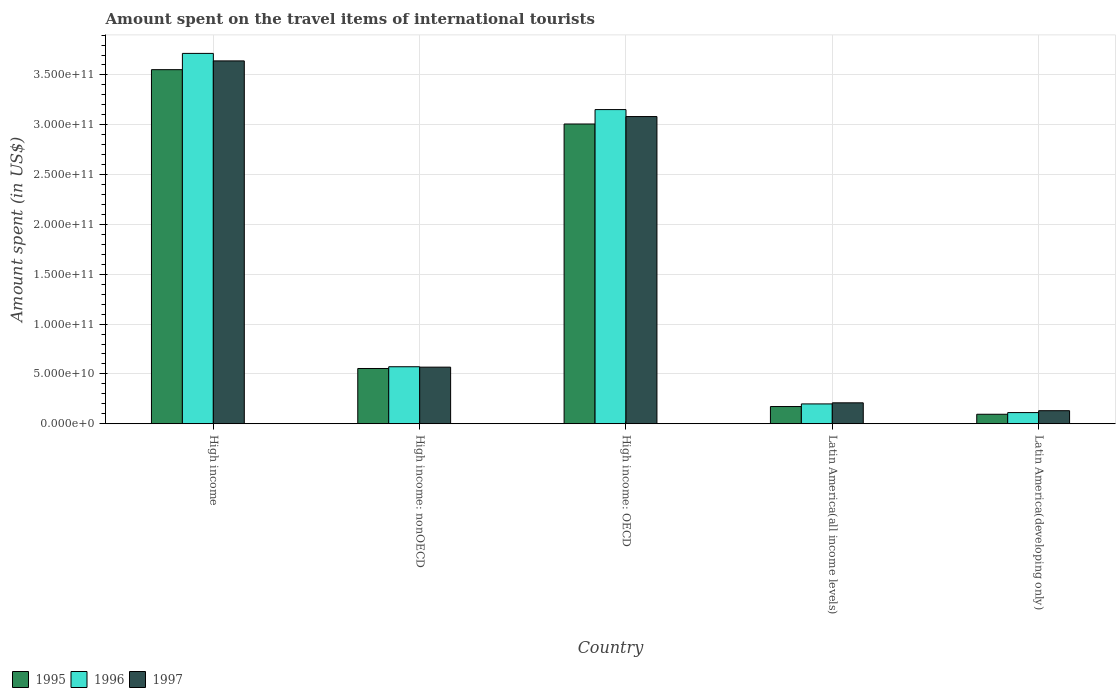How many different coloured bars are there?
Provide a short and direct response. 3. How many groups of bars are there?
Give a very brief answer. 5. Are the number of bars per tick equal to the number of legend labels?
Provide a succinct answer. Yes. What is the label of the 5th group of bars from the left?
Ensure brevity in your answer.  Latin America(developing only). What is the amount spent on the travel items of international tourists in 1995 in High income?
Ensure brevity in your answer.  3.55e+11. Across all countries, what is the maximum amount spent on the travel items of international tourists in 1995?
Your answer should be compact. 3.55e+11. Across all countries, what is the minimum amount spent on the travel items of international tourists in 1996?
Ensure brevity in your answer.  1.12e+1. In which country was the amount spent on the travel items of international tourists in 1995 maximum?
Ensure brevity in your answer.  High income. In which country was the amount spent on the travel items of international tourists in 1996 minimum?
Give a very brief answer. Latin America(developing only). What is the total amount spent on the travel items of international tourists in 1996 in the graph?
Provide a short and direct response. 7.75e+11. What is the difference between the amount spent on the travel items of international tourists in 1997 in High income: OECD and that in Latin America(all income levels)?
Make the answer very short. 2.87e+11. What is the difference between the amount spent on the travel items of international tourists in 1996 in Latin America(all income levels) and the amount spent on the travel items of international tourists in 1997 in High income: nonOECD?
Provide a short and direct response. -3.69e+1. What is the average amount spent on the travel items of international tourists in 1995 per country?
Ensure brevity in your answer.  1.48e+11. What is the difference between the amount spent on the travel items of international tourists of/in 1996 and amount spent on the travel items of international tourists of/in 1995 in High income?
Your answer should be compact. 1.63e+1. In how many countries, is the amount spent on the travel items of international tourists in 1995 greater than 260000000000 US$?
Ensure brevity in your answer.  2. What is the ratio of the amount spent on the travel items of international tourists in 1995 in High income: OECD to that in Latin America(all income levels)?
Offer a very short reply. 17.42. What is the difference between the highest and the second highest amount spent on the travel items of international tourists in 1997?
Provide a short and direct response. -5.59e+1. What is the difference between the highest and the lowest amount spent on the travel items of international tourists in 1997?
Your response must be concise. 3.51e+11. In how many countries, is the amount spent on the travel items of international tourists in 1997 greater than the average amount spent on the travel items of international tourists in 1997 taken over all countries?
Your response must be concise. 2. Is the sum of the amount spent on the travel items of international tourists in 1997 in High income: OECD and Latin America(developing only) greater than the maximum amount spent on the travel items of international tourists in 1995 across all countries?
Ensure brevity in your answer.  No. What does the 2nd bar from the right in High income represents?
Offer a terse response. 1996. How many bars are there?
Your answer should be compact. 15. Does the graph contain any zero values?
Give a very brief answer. No. Does the graph contain grids?
Offer a terse response. Yes. How many legend labels are there?
Keep it short and to the point. 3. What is the title of the graph?
Provide a succinct answer. Amount spent on the travel items of international tourists. What is the label or title of the X-axis?
Ensure brevity in your answer.  Country. What is the label or title of the Y-axis?
Keep it short and to the point. Amount spent (in US$). What is the Amount spent (in US$) of 1995 in High income?
Offer a very short reply. 3.55e+11. What is the Amount spent (in US$) of 1996 in High income?
Your answer should be very brief. 3.72e+11. What is the Amount spent (in US$) of 1997 in High income?
Give a very brief answer. 3.64e+11. What is the Amount spent (in US$) of 1995 in High income: nonOECD?
Ensure brevity in your answer.  5.54e+1. What is the Amount spent (in US$) of 1996 in High income: nonOECD?
Keep it short and to the point. 5.72e+1. What is the Amount spent (in US$) of 1997 in High income: nonOECD?
Provide a short and direct response. 5.68e+1. What is the Amount spent (in US$) of 1995 in High income: OECD?
Keep it short and to the point. 3.01e+11. What is the Amount spent (in US$) of 1996 in High income: OECD?
Make the answer very short. 3.15e+11. What is the Amount spent (in US$) in 1997 in High income: OECD?
Make the answer very short. 3.08e+11. What is the Amount spent (in US$) of 1995 in Latin America(all income levels)?
Your answer should be compact. 1.73e+1. What is the Amount spent (in US$) in 1996 in Latin America(all income levels)?
Give a very brief answer. 1.99e+1. What is the Amount spent (in US$) in 1997 in Latin America(all income levels)?
Provide a succinct answer. 2.10e+1. What is the Amount spent (in US$) in 1995 in Latin America(developing only)?
Ensure brevity in your answer.  9.52e+09. What is the Amount spent (in US$) in 1996 in Latin America(developing only)?
Keep it short and to the point. 1.12e+1. What is the Amount spent (in US$) in 1997 in Latin America(developing only)?
Your answer should be very brief. 1.31e+1. Across all countries, what is the maximum Amount spent (in US$) of 1995?
Offer a terse response. 3.55e+11. Across all countries, what is the maximum Amount spent (in US$) of 1996?
Ensure brevity in your answer.  3.72e+11. Across all countries, what is the maximum Amount spent (in US$) in 1997?
Offer a very short reply. 3.64e+11. Across all countries, what is the minimum Amount spent (in US$) in 1995?
Your response must be concise. 9.52e+09. Across all countries, what is the minimum Amount spent (in US$) of 1996?
Make the answer very short. 1.12e+1. Across all countries, what is the minimum Amount spent (in US$) of 1997?
Ensure brevity in your answer.  1.31e+1. What is the total Amount spent (in US$) of 1995 in the graph?
Ensure brevity in your answer.  7.38e+11. What is the total Amount spent (in US$) in 1996 in the graph?
Offer a terse response. 7.75e+11. What is the total Amount spent (in US$) of 1997 in the graph?
Offer a very short reply. 7.63e+11. What is the difference between the Amount spent (in US$) in 1995 in High income and that in High income: nonOECD?
Keep it short and to the point. 3.00e+11. What is the difference between the Amount spent (in US$) in 1996 in High income and that in High income: nonOECD?
Give a very brief answer. 3.14e+11. What is the difference between the Amount spent (in US$) in 1997 in High income and that in High income: nonOECD?
Give a very brief answer. 3.07e+11. What is the difference between the Amount spent (in US$) of 1995 in High income and that in High income: OECD?
Ensure brevity in your answer.  5.45e+1. What is the difference between the Amount spent (in US$) of 1996 in High income and that in High income: OECD?
Keep it short and to the point. 5.64e+1. What is the difference between the Amount spent (in US$) in 1997 in High income and that in High income: OECD?
Offer a terse response. 5.59e+1. What is the difference between the Amount spent (in US$) in 1995 in High income and that in Latin America(all income levels)?
Make the answer very short. 3.38e+11. What is the difference between the Amount spent (in US$) of 1996 in High income and that in Latin America(all income levels)?
Provide a succinct answer. 3.52e+11. What is the difference between the Amount spent (in US$) of 1997 in High income and that in Latin America(all income levels)?
Provide a succinct answer. 3.43e+11. What is the difference between the Amount spent (in US$) of 1995 in High income and that in Latin America(developing only)?
Your response must be concise. 3.46e+11. What is the difference between the Amount spent (in US$) in 1996 in High income and that in Latin America(developing only)?
Keep it short and to the point. 3.60e+11. What is the difference between the Amount spent (in US$) of 1997 in High income and that in Latin America(developing only)?
Provide a short and direct response. 3.51e+11. What is the difference between the Amount spent (in US$) of 1995 in High income: nonOECD and that in High income: OECD?
Provide a short and direct response. -2.45e+11. What is the difference between the Amount spent (in US$) in 1996 in High income: nonOECD and that in High income: OECD?
Make the answer very short. -2.58e+11. What is the difference between the Amount spent (in US$) of 1997 in High income: nonOECD and that in High income: OECD?
Offer a very short reply. -2.51e+11. What is the difference between the Amount spent (in US$) in 1995 in High income: nonOECD and that in Latin America(all income levels)?
Keep it short and to the point. 3.82e+1. What is the difference between the Amount spent (in US$) of 1996 in High income: nonOECD and that in Latin America(all income levels)?
Offer a very short reply. 3.73e+1. What is the difference between the Amount spent (in US$) of 1997 in High income: nonOECD and that in Latin America(all income levels)?
Offer a terse response. 3.58e+1. What is the difference between the Amount spent (in US$) of 1995 in High income: nonOECD and that in Latin America(developing only)?
Your response must be concise. 4.59e+1. What is the difference between the Amount spent (in US$) of 1996 in High income: nonOECD and that in Latin America(developing only)?
Keep it short and to the point. 4.60e+1. What is the difference between the Amount spent (in US$) in 1997 in High income: nonOECD and that in Latin America(developing only)?
Your response must be concise. 4.37e+1. What is the difference between the Amount spent (in US$) in 1995 in High income: OECD and that in Latin America(all income levels)?
Ensure brevity in your answer.  2.84e+11. What is the difference between the Amount spent (in US$) of 1996 in High income: OECD and that in Latin America(all income levels)?
Ensure brevity in your answer.  2.95e+11. What is the difference between the Amount spent (in US$) of 1997 in High income: OECD and that in Latin America(all income levels)?
Keep it short and to the point. 2.87e+11. What is the difference between the Amount spent (in US$) of 1995 in High income: OECD and that in Latin America(developing only)?
Provide a succinct answer. 2.91e+11. What is the difference between the Amount spent (in US$) of 1996 in High income: OECD and that in Latin America(developing only)?
Provide a short and direct response. 3.04e+11. What is the difference between the Amount spent (in US$) of 1997 in High income: OECD and that in Latin America(developing only)?
Provide a succinct answer. 2.95e+11. What is the difference between the Amount spent (in US$) in 1995 in Latin America(all income levels) and that in Latin America(developing only)?
Make the answer very short. 7.75e+09. What is the difference between the Amount spent (in US$) of 1996 in Latin America(all income levels) and that in Latin America(developing only)?
Make the answer very short. 8.70e+09. What is the difference between the Amount spent (in US$) in 1997 in Latin America(all income levels) and that in Latin America(developing only)?
Keep it short and to the point. 7.89e+09. What is the difference between the Amount spent (in US$) of 1995 in High income and the Amount spent (in US$) of 1996 in High income: nonOECD?
Make the answer very short. 2.98e+11. What is the difference between the Amount spent (in US$) of 1995 in High income and the Amount spent (in US$) of 1997 in High income: nonOECD?
Offer a very short reply. 2.99e+11. What is the difference between the Amount spent (in US$) in 1996 in High income and the Amount spent (in US$) in 1997 in High income: nonOECD?
Your answer should be very brief. 3.15e+11. What is the difference between the Amount spent (in US$) in 1995 in High income and the Amount spent (in US$) in 1996 in High income: OECD?
Give a very brief answer. 4.01e+1. What is the difference between the Amount spent (in US$) of 1995 in High income and the Amount spent (in US$) of 1997 in High income: OECD?
Your answer should be very brief. 4.71e+1. What is the difference between the Amount spent (in US$) of 1996 in High income and the Amount spent (in US$) of 1997 in High income: OECD?
Your answer should be compact. 6.34e+1. What is the difference between the Amount spent (in US$) in 1995 in High income and the Amount spent (in US$) in 1996 in Latin America(all income levels)?
Keep it short and to the point. 3.35e+11. What is the difference between the Amount spent (in US$) of 1995 in High income and the Amount spent (in US$) of 1997 in Latin America(all income levels)?
Offer a terse response. 3.34e+11. What is the difference between the Amount spent (in US$) in 1996 in High income and the Amount spent (in US$) in 1997 in Latin America(all income levels)?
Ensure brevity in your answer.  3.51e+11. What is the difference between the Amount spent (in US$) in 1995 in High income and the Amount spent (in US$) in 1996 in Latin America(developing only)?
Offer a terse response. 3.44e+11. What is the difference between the Amount spent (in US$) of 1995 in High income and the Amount spent (in US$) of 1997 in Latin America(developing only)?
Offer a terse response. 3.42e+11. What is the difference between the Amount spent (in US$) in 1996 in High income and the Amount spent (in US$) in 1997 in Latin America(developing only)?
Provide a short and direct response. 3.59e+11. What is the difference between the Amount spent (in US$) of 1995 in High income: nonOECD and the Amount spent (in US$) of 1996 in High income: OECD?
Provide a succinct answer. -2.60e+11. What is the difference between the Amount spent (in US$) in 1995 in High income: nonOECD and the Amount spent (in US$) in 1997 in High income: OECD?
Your answer should be compact. -2.53e+11. What is the difference between the Amount spent (in US$) in 1996 in High income: nonOECD and the Amount spent (in US$) in 1997 in High income: OECD?
Your response must be concise. -2.51e+11. What is the difference between the Amount spent (in US$) of 1995 in High income: nonOECD and the Amount spent (in US$) of 1996 in Latin America(all income levels)?
Give a very brief answer. 3.55e+1. What is the difference between the Amount spent (in US$) of 1995 in High income: nonOECD and the Amount spent (in US$) of 1997 in Latin America(all income levels)?
Ensure brevity in your answer.  3.44e+1. What is the difference between the Amount spent (in US$) in 1996 in High income: nonOECD and the Amount spent (in US$) in 1997 in Latin America(all income levels)?
Provide a short and direct response. 3.62e+1. What is the difference between the Amount spent (in US$) in 1995 in High income: nonOECD and the Amount spent (in US$) in 1996 in Latin America(developing only)?
Make the answer very short. 4.42e+1. What is the difference between the Amount spent (in US$) in 1995 in High income: nonOECD and the Amount spent (in US$) in 1997 in Latin America(developing only)?
Give a very brief answer. 4.23e+1. What is the difference between the Amount spent (in US$) in 1996 in High income: nonOECD and the Amount spent (in US$) in 1997 in Latin America(developing only)?
Offer a terse response. 4.41e+1. What is the difference between the Amount spent (in US$) of 1995 in High income: OECD and the Amount spent (in US$) of 1996 in Latin America(all income levels)?
Provide a short and direct response. 2.81e+11. What is the difference between the Amount spent (in US$) of 1995 in High income: OECD and the Amount spent (in US$) of 1997 in Latin America(all income levels)?
Give a very brief answer. 2.80e+11. What is the difference between the Amount spent (in US$) in 1996 in High income: OECD and the Amount spent (in US$) in 1997 in Latin America(all income levels)?
Your answer should be compact. 2.94e+11. What is the difference between the Amount spent (in US$) in 1995 in High income: OECD and the Amount spent (in US$) in 1996 in Latin America(developing only)?
Provide a succinct answer. 2.90e+11. What is the difference between the Amount spent (in US$) in 1995 in High income: OECD and the Amount spent (in US$) in 1997 in Latin America(developing only)?
Offer a very short reply. 2.88e+11. What is the difference between the Amount spent (in US$) in 1996 in High income: OECD and the Amount spent (in US$) in 1997 in Latin America(developing only)?
Provide a short and direct response. 3.02e+11. What is the difference between the Amount spent (in US$) in 1995 in Latin America(all income levels) and the Amount spent (in US$) in 1996 in Latin America(developing only)?
Provide a succinct answer. 6.08e+09. What is the difference between the Amount spent (in US$) in 1995 in Latin America(all income levels) and the Amount spent (in US$) in 1997 in Latin America(developing only)?
Ensure brevity in your answer.  4.17e+09. What is the difference between the Amount spent (in US$) in 1996 in Latin America(all income levels) and the Amount spent (in US$) in 1997 in Latin America(developing only)?
Provide a succinct answer. 6.80e+09. What is the average Amount spent (in US$) in 1995 per country?
Ensure brevity in your answer.  1.48e+11. What is the average Amount spent (in US$) of 1996 per country?
Ensure brevity in your answer.  1.55e+11. What is the average Amount spent (in US$) of 1997 per country?
Keep it short and to the point. 1.53e+11. What is the difference between the Amount spent (in US$) in 1995 and Amount spent (in US$) in 1996 in High income?
Provide a short and direct response. -1.63e+1. What is the difference between the Amount spent (in US$) of 1995 and Amount spent (in US$) of 1997 in High income?
Provide a short and direct response. -8.79e+09. What is the difference between the Amount spent (in US$) of 1996 and Amount spent (in US$) of 1997 in High income?
Provide a succinct answer. 7.54e+09. What is the difference between the Amount spent (in US$) in 1995 and Amount spent (in US$) in 1996 in High income: nonOECD?
Your response must be concise. -1.77e+09. What is the difference between the Amount spent (in US$) of 1995 and Amount spent (in US$) of 1997 in High income: nonOECD?
Your response must be concise. -1.35e+09. What is the difference between the Amount spent (in US$) of 1996 and Amount spent (in US$) of 1997 in High income: nonOECD?
Offer a very short reply. 4.21e+08. What is the difference between the Amount spent (in US$) of 1995 and Amount spent (in US$) of 1996 in High income: OECD?
Ensure brevity in your answer.  -1.45e+1. What is the difference between the Amount spent (in US$) of 1995 and Amount spent (in US$) of 1997 in High income: OECD?
Keep it short and to the point. -7.46e+09. What is the difference between the Amount spent (in US$) of 1996 and Amount spent (in US$) of 1997 in High income: OECD?
Offer a terse response. 7.00e+09. What is the difference between the Amount spent (in US$) in 1995 and Amount spent (in US$) in 1996 in Latin America(all income levels)?
Offer a very short reply. -2.62e+09. What is the difference between the Amount spent (in US$) of 1995 and Amount spent (in US$) of 1997 in Latin America(all income levels)?
Provide a succinct answer. -3.72e+09. What is the difference between the Amount spent (in US$) of 1996 and Amount spent (in US$) of 1997 in Latin America(all income levels)?
Your answer should be very brief. -1.10e+09. What is the difference between the Amount spent (in US$) of 1995 and Amount spent (in US$) of 1996 in Latin America(developing only)?
Offer a terse response. -1.67e+09. What is the difference between the Amount spent (in US$) in 1995 and Amount spent (in US$) in 1997 in Latin America(developing only)?
Provide a short and direct response. -3.58e+09. What is the difference between the Amount spent (in US$) of 1996 and Amount spent (in US$) of 1997 in Latin America(developing only)?
Offer a very short reply. -1.91e+09. What is the ratio of the Amount spent (in US$) of 1995 in High income to that in High income: nonOECD?
Your answer should be very brief. 6.41. What is the ratio of the Amount spent (in US$) of 1996 in High income to that in High income: nonOECD?
Your answer should be very brief. 6.5. What is the ratio of the Amount spent (in US$) in 1997 in High income to that in High income: nonOECD?
Make the answer very short. 6.41. What is the ratio of the Amount spent (in US$) in 1995 in High income to that in High income: OECD?
Keep it short and to the point. 1.18. What is the ratio of the Amount spent (in US$) in 1996 in High income to that in High income: OECD?
Your answer should be very brief. 1.18. What is the ratio of the Amount spent (in US$) of 1997 in High income to that in High income: OECD?
Make the answer very short. 1.18. What is the ratio of the Amount spent (in US$) in 1995 in High income to that in Latin America(all income levels)?
Provide a succinct answer. 20.58. What is the ratio of the Amount spent (in US$) in 1996 in High income to that in Latin America(all income levels)?
Offer a terse response. 18.68. What is the ratio of the Amount spent (in US$) of 1997 in High income to that in Latin America(all income levels)?
Provide a succinct answer. 17.35. What is the ratio of the Amount spent (in US$) of 1995 in High income to that in Latin America(developing only)?
Ensure brevity in your answer.  37.33. What is the ratio of the Amount spent (in US$) in 1996 in High income to that in Latin America(developing only)?
Give a very brief answer. 33.22. What is the ratio of the Amount spent (in US$) of 1997 in High income to that in Latin America(developing only)?
Keep it short and to the point. 27.81. What is the ratio of the Amount spent (in US$) in 1995 in High income: nonOECD to that in High income: OECD?
Your answer should be very brief. 0.18. What is the ratio of the Amount spent (in US$) in 1996 in High income: nonOECD to that in High income: OECD?
Give a very brief answer. 0.18. What is the ratio of the Amount spent (in US$) in 1997 in High income: nonOECD to that in High income: OECD?
Give a very brief answer. 0.18. What is the ratio of the Amount spent (in US$) in 1995 in High income: nonOECD to that in Latin America(all income levels)?
Ensure brevity in your answer.  3.21. What is the ratio of the Amount spent (in US$) in 1996 in High income: nonOECD to that in Latin America(all income levels)?
Offer a very short reply. 2.88. What is the ratio of the Amount spent (in US$) of 1997 in High income: nonOECD to that in Latin America(all income levels)?
Provide a short and direct response. 2.71. What is the ratio of the Amount spent (in US$) in 1995 in High income: nonOECD to that in Latin America(developing only)?
Ensure brevity in your answer.  5.82. What is the ratio of the Amount spent (in US$) of 1996 in High income: nonOECD to that in Latin America(developing only)?
Offer a terse response. 5.11. What is the ratio of the Amount spent (in US$) in 1997 in High income: nonOECD to that in Latin America(developing only)?
Your answer should be very brief. 4.34. What is the ratio of the Amount spent (in US$) in 1995 in High income: OECD to that in Latin America(all income levels)?
Ensure brevity in your answer.  17.42. What is the ratio of the Amount spent (in US$) in 1996 in High income: OECD to that in Latin America(all income levels)?
Ensure brevity in your answer.  15.85. What is the ratio of the Amount spent (in US$) in 1997 in High income: OECD to that in Latin America(all income levels)?
Provide a short and direct response. 14.69. What is the ratio of the Amount spent (in US$) of 1995 in High income: OECD to that in Latin America(developing only)?
Give a very brief answer. 31.61. What is the ratio of the Amount spent (in US$) in 1996 in High income: OECD to that in Latin America(developing only)?
Keep it short and to the point. 28.18. What is the ratio of the Amount spent (in US$) in 1997 in High income: OECD to that in Latin America(developing only)?
Keep it short and to the point. 23.54. What is the ratio of the Amount spent (in US$) in 1995 in Latin America(all income levels) to that in Latin America(developing only)?
Keep it short and to the point. 1.81. What is the ratio of the Amount spent (in US$) of 1996 in Latin America(all income levels) to that in Latin America(developing only)?
Offer a very short reply. 1.78. What is the ratio of the Amount spent (in US$) in 1997 in Latin America(all income levels) to that in Latin America(developing only)?
Give a very brief answer. 1.6. What is the difference between the highest and the second highest Amount spent (in US$) in 1995?
Offer a terse response. 5.45e+1. What is the difference between the highest and the second highest Amount spent (in US$) of 1996?
Offer a terse response. 5.64e+1. What is the difference between the highest and the second highest Amount spent (in US$) of 1997?
Your response must be concise. 5.59e+1. What is the difference between the highest and the lowest Amount spent (in US$) in 1995?
Provide a succinct answer. 3.46e+11. What is the difference between the highest and the lowest Amount spent (in US$) of 1996?
Give a very brief answer. 3.60e+11. What is the difference between the highest and the lowest Amount spent (in US$) in 1997?
Your answer should be compact. 3.51e+11. 